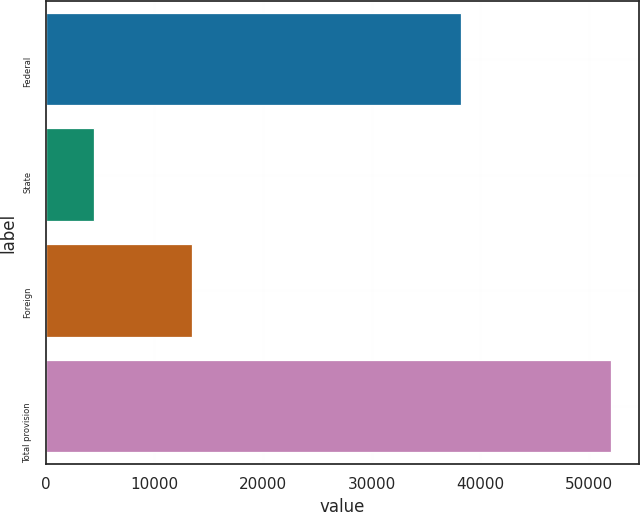Convert chart to OTSL. <chart><loc_0><loc_0><loc_500><loc_500><bar_chart><fcel>Federal<fcel>State<fcel>Foreign<fcel>Total provision<nl><fcel>38249<fcel>4413<fcel>13483<fcel>51971<nl></chart> 